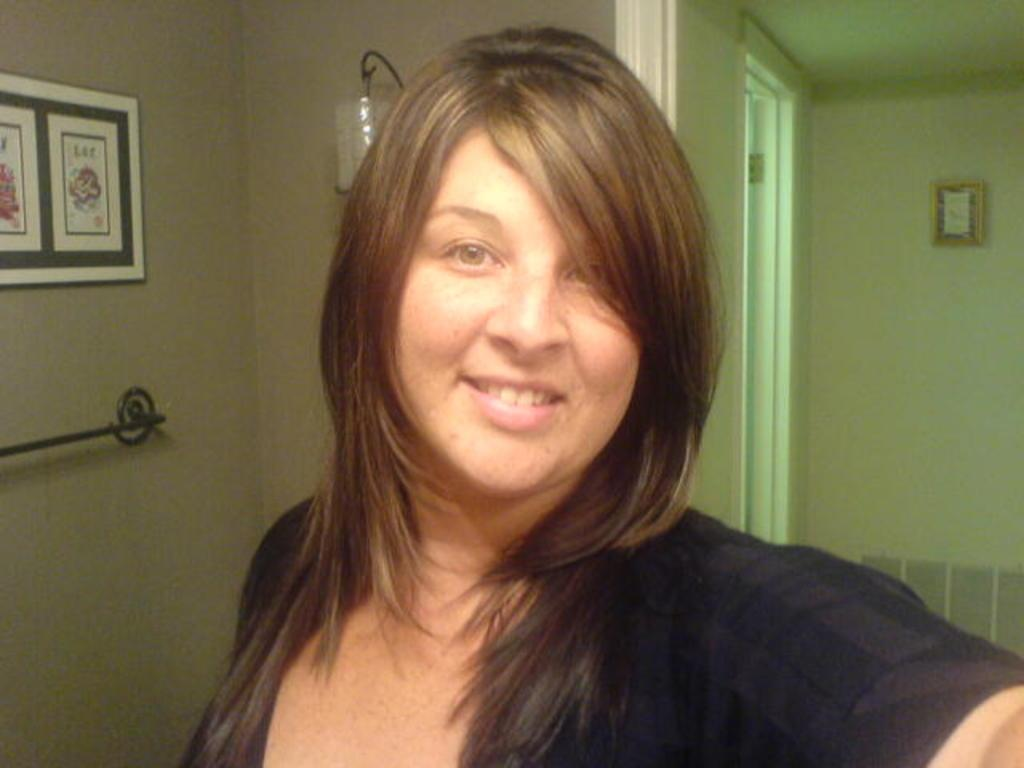Who is present in the image? There is a woman in the image. What is the woman wearing? The woman is wearing a black dress. What can be seen in the background of the image? There is a wall in the background of the image. What is on the wall in the background? There are frames on the wall in the background. What type of shade is covering the woman's legs in the image? There is no shade covering the woman's legs in the image, as she is not depicted as being outdoors or near any structures that would cast a shadow. 